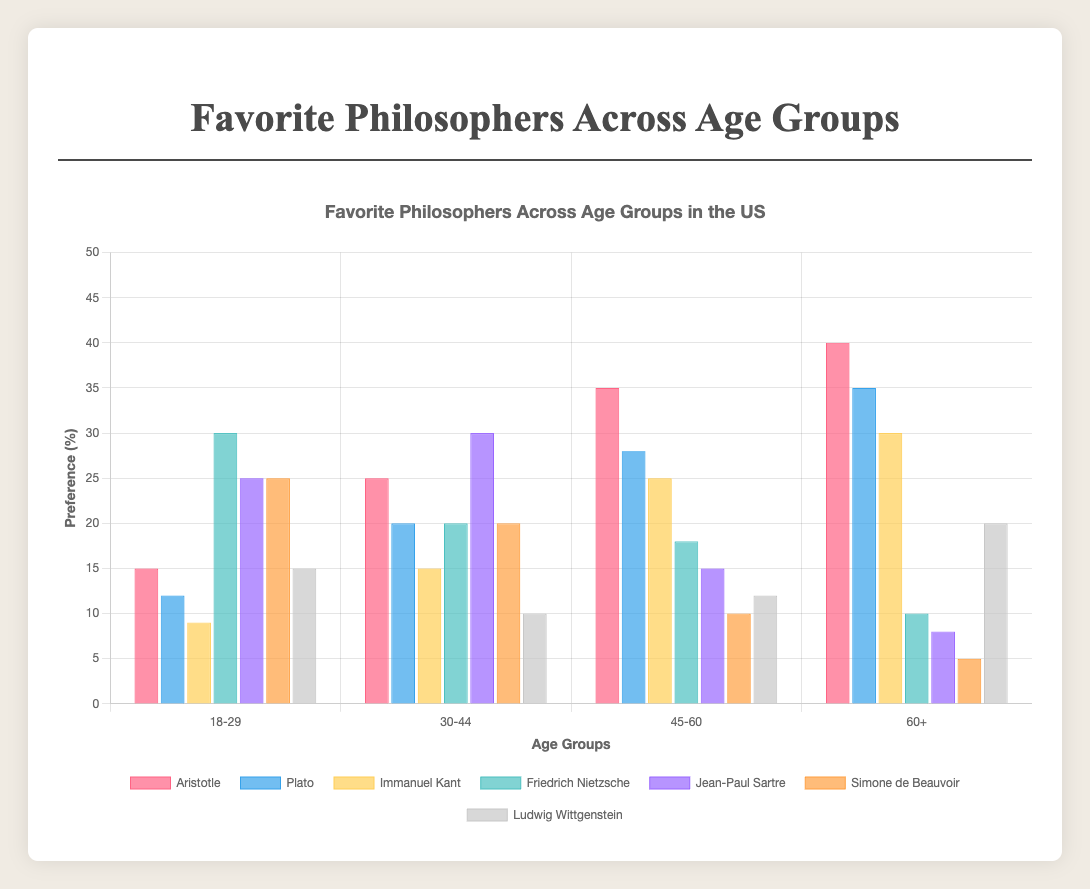What is the most popular philosopher among the 18-29 age group? From the figure, for the age group 18-29, the bar representing Friedrich Nietzsche is the highest, indicating he is the most popular philosopher in this group.
Answer: Friedrich Nietzsche Which age group has the highest preference for Aristotle? From the figure, the age group 60+ has the highest bar for Aristotle, indicating the highest preference for him.
Answer: 60+ Compare the popularity of Jean-Paul Sartre between the 18-29 and 60+ age groups. By looking at the bars for Jean-Paul Sartre, the bar is much higher in the 18-29 age group compared to the 60+ age group, indicating that Sartre is more popular among the younger group.
Answer: 18-29 Which philosopher sees a consistent increase in preference with increasing age groups? Aristotle's bars consistently increase in height from the 18-29 age group to the 60+ age group, indicating a consistent increase in popularity as age increases.
Answer: Aristotle What is the highest preference (%) recorded for a single philosopher across all age groups, and who does it represent? The highest bar in the figure corresponds to Friedrich Nietzsche in the 18-29 age group, with a preference of 30%.
Answer: Friedrich Nietzsche, 30% For the 30-44 age group, what is the sum of the preferences for Plato and Immanuel Kant? The preferences for Plato and Immanuel Kant in the 30-44 age group are 20% and 15% respectively. Their sum is 20 + 15 = 35%.
Answer: 35% How does the popularity of Simone de Beauvoir change from the 18-29 age group to the 45-60 age group? In the figure, Simone de Beauvoir's bar is at 25% in the 18-29 age group and decreases to 10% in the 45-60 age group, indicating a decrease in popularity.
Answer: Decrease Which philosopher's preference has the least variation across all age groups? Ludwig Wittgenstein's bars are relatively uniform across all age groups, indicating the least variation in preference.
Answer: Ludwig Wittgenstein What is the average preference (%) for Plato across all age groups? Summing the preferences for Plato across all age groups (12 + 20 + 28 + 35) gives 95. The average is 95 / 4 = 23.75%.
Answer: 23.75% In which age group does Immanuel Kant have the second-highest preference? For Immanuel Kant, the figure shows the second-highest bar in the 60+ age group after Aristotle.
Answer: 60+ 